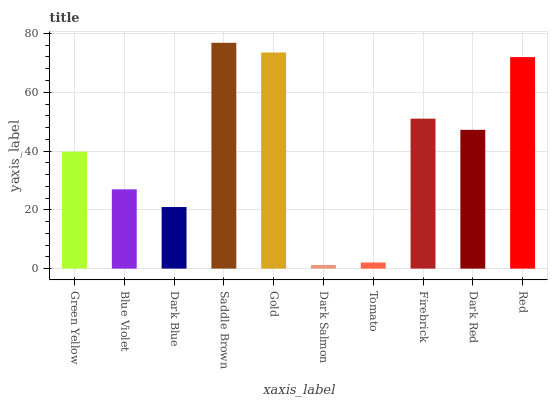Is Dark Salmon the minimum?
Answer yes or no. Yes. Is Saddle Brown the maximum?
Answer yes or no. Yes. Is Blue Violet the minimum?
Answer yes or no. No. Is Blue Violet the maximum?
Answer yes or no. No. Is Green Yellow greater than Blue Violet?
Answer yes or no. Yes. Is Blue Violet less than Green Yellow?
Answer yes or no. Yes. Is Blue Violet greater than Green Yellow?
Answer yes or no. No. Is Green Yellow less than Blue Violet?
Answer yes or no. No. Is Dark Red the high median?
Answer yes or no. Yes. Is Green Yellow the low median?
Answer yes or no. Yes. Is Tomato the high median?
Answer yes or no. No. Is Saddle Brown the low median?
Answer yes or no. No. 